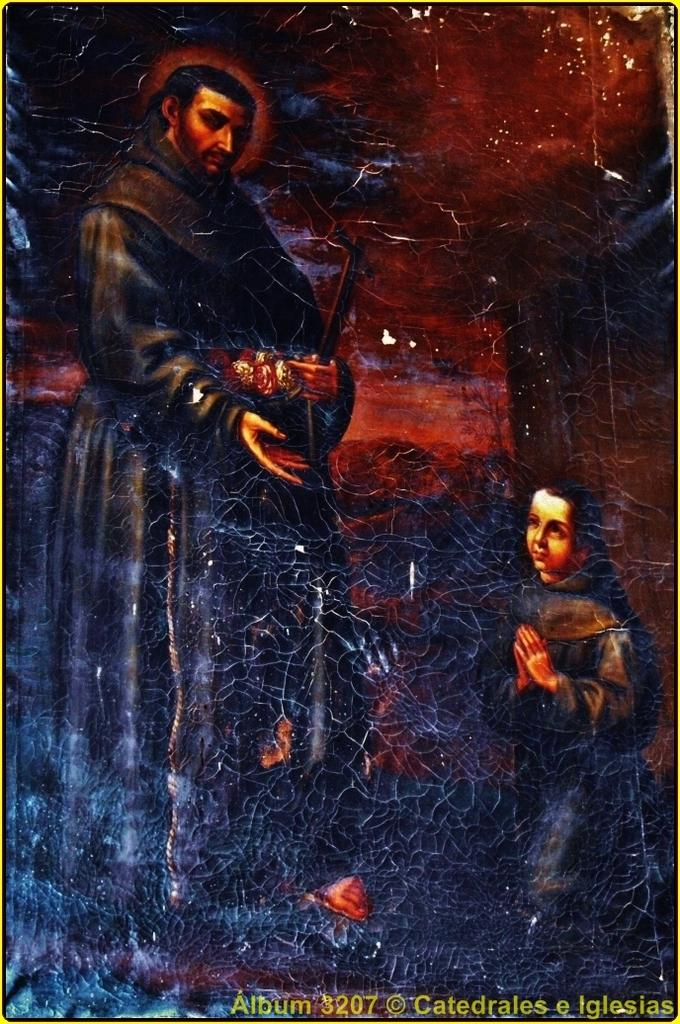<image>
Create a compact narrative representing the image presented. A religious picture that is part of album 3207. 